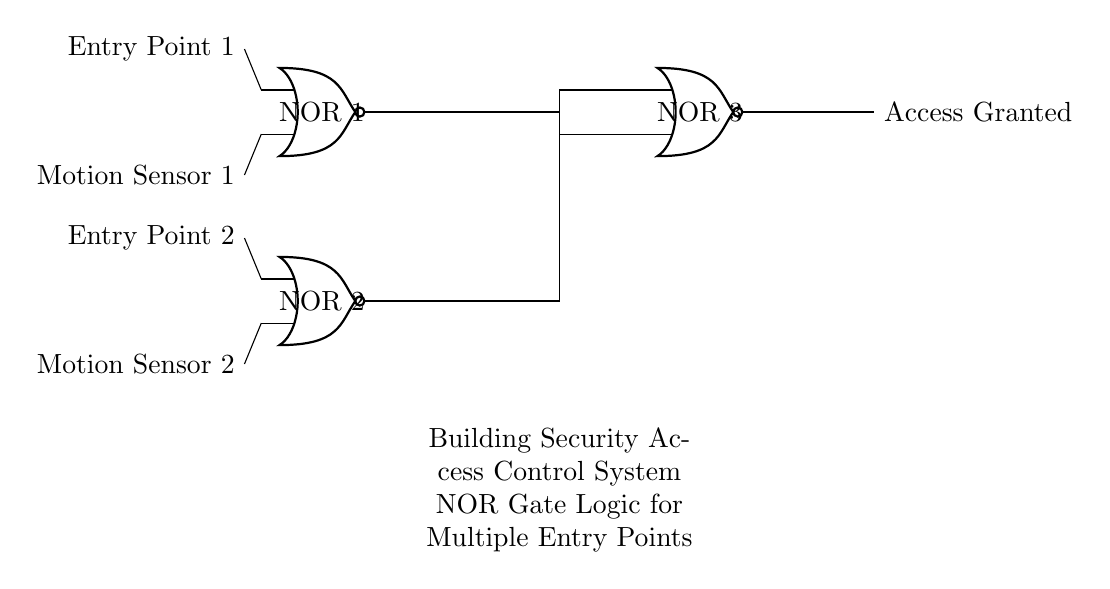What are the types of gates used in the circuit? The circuit employs NOR gates, which are indicated by the labeled components in the diagram. There are three NOR gates shown.
Answer: NOR gates How many entry points are there in this system? The diagram specifies two entry points, labeled as Entry Point 1 and Entry Point 2. Each entry point is associated with a motion sensor.
Answer: Two What do the outputs of the NOR gates represent? The outputs of the NOR gates signify whether access is granted, indicated by the label "Access Granted" linked to the output of NOR gate 3.
Answer: Access Granted How many motion sensors are connected to the circuit? There are two motion sensors connected, one for each entry point, clearly labeled in the diagram.
Answer: Two What is the function of NOR gate 3 in the circuit? NOR gate 3 receives outputs from the first two NOR gates and ultimately determines if access is granted based on those outputs. If both inputs to NOR gate 3 are low, it will output high, granting access.
Answer: Determine access If both entry point inputs are activated, what will be the output? If both entry points are activated, both NOR gate inputs become high, resulting in a low output from each of the first two NOR gates, which leads NOR gate 3 to output high, granting access.
Answer: High output 